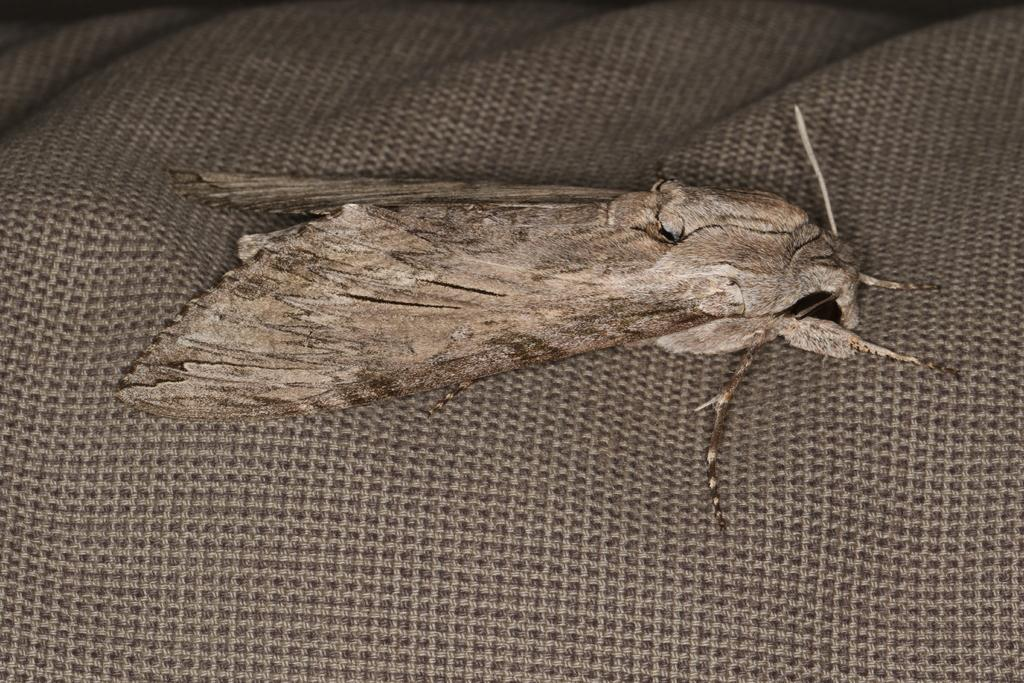What type of creature is present in the image? There is an insect in the image. Where is the insect located? The insect is on a mat. Can you describe the position of the insect in the image? The insect is located in the center of the image. What type of art is the insect creating with its partner on the mat? There is no art or partner present in the image; it only features an insect on a mat. 